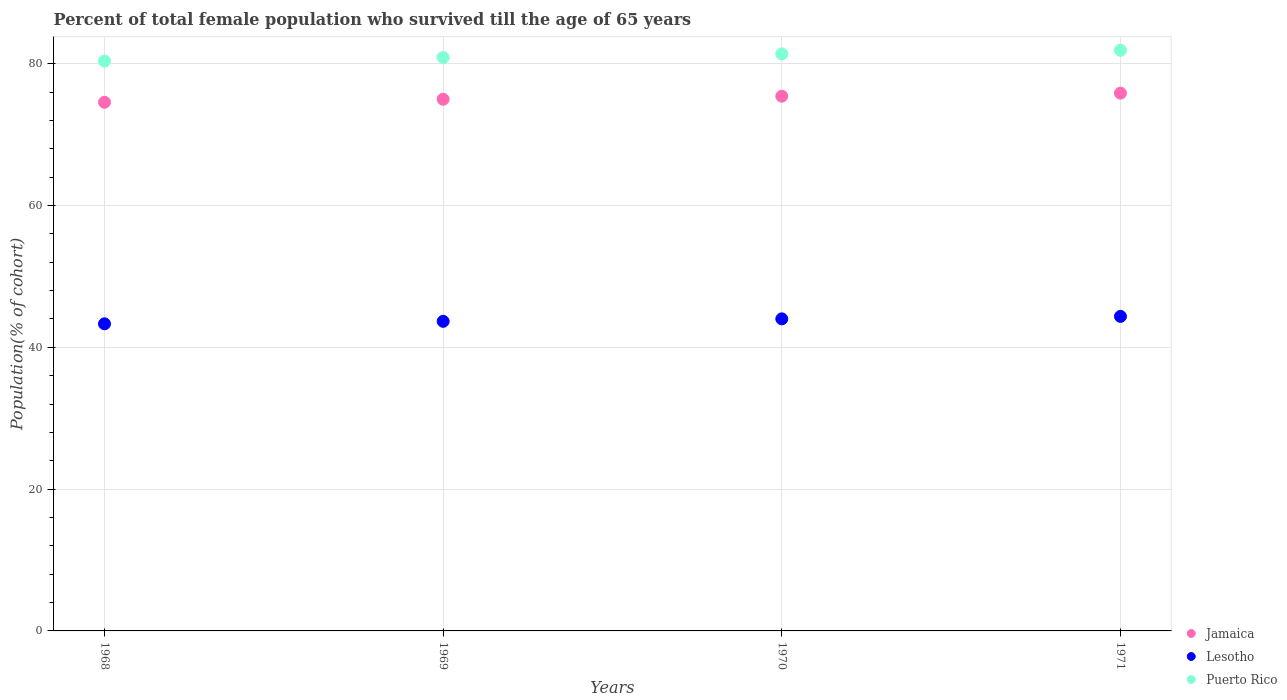What is the percentage of total female population who survived till the age of 65 years in Jamaica in 1969?
Ensure brevity in your answer.  74.99. Across all years, what is the maximum percentage of total female population who survived till the age of 65 years in Jamaica?
Provide a succinct answer. 75.85. Across all years, what is the minimum percentage of total female population who survived till the age of 65 years in Jamaica?
Give a very brief answer. 74.56. In which year was the percentage of total female population who survived till the age of 65 years in Jamaica maximum?
Offer a terse response. 1971. In which year was the percentage of total female population who survived till the age of 65 years in Jamaica minimum?
Provide a short and direct response. 1968. What is the total percentage of total female population who survived till the age of 65 years in Lesotho in the graph?
Offer a very short reply. 175.35. What is the difference between the percentage of total female population who survived till the age of 65 years in Puerto Rico in 1968 and that in 1969?
Offer a terse response. -0.51. What is the difference between the percentage of total female population who survived till the age of 65 years in Puerto Rico in 1971 and the percentage of total female population who survived till the age of 65 years in Lesotho in 1968?
Give a very brief answer. 38.58. What is the average percentage of total female population who survived till the age of 65 years in Lesotho per year?
Keep it short and to the point. 43.84. In the year 1971, what is the difference between the percentage of total female population who survived till the age of 65 years in Jamaica and percentage of total female population who survived till the age of 65 years in Puerto Rico?
Make the answer very short. -6.05. In how many years, is the percentage of total female population who survived till the age of 65 years in Jamaica greater than 40 %?
Give a very brief answer. 4. What is the ratio of the percentage of total female population who survived till the age of 65 years in Jamaica in 1970 to that in 1971?
Keep it short and to the point. 0.99. Is the percentage of total female population who survived till the age of 65 years in Lesotho in 1969 less than that in 1971?
Offer a very short reply. Yes. Is the difference between the percentage of total female population who survived till the age of 65 years in Jamaica in 1970 and 1971 greater than the difference between the percentage of total female population who survived till the age of 65 years in Puerto Rico in 1970 and 1971?
Give a very brief answer. Yes. What is the difference between the highest and the second highest percentage of total female population who survived till the age of 65 years in Jamaica?
Your response must be concise. 0.43. What is the difference between the highest and the lowest percentage of total female population who survived till the age of 65 years in Puerto Rico?
Provide a short and direct response. 1.53. In how many years, is the percentage of total female population who survived till the age of 65 years in Jamaica greater than the average percentage of total female population who survived till the age of 65 years in Jamaica taken over all years?
Offer a terse response. 2. Is it the case that in every year, the sum of the percentage of total female population who survived till the age of 65 years in Puerto Rico and percentage of total female population who survived till the age of 65 years in Lesotho  is greater than the percentage of total female population who survived till the age of 65 years in Jamaica?
Provide a succinct answer. Yes. How many dotlines are there?
Ensure brevity in your answer.  3. Are the values on the major ticks of Y-axis written in scientific E-notation?
Provide a succinct answer. No. Does the graph contain any zero values?
Make the answer very short. No. Does the graph contain grids?
Provide a succinct answer. Yes. Where does the legend appear in the graph?
Give a very brief answer. Bottom right. How are the legend labels stacked?
Your answer should be very brief. Vertical. What is the title of the graph?
Give a very brief answer. Percent of total female population who survived till the age of 65 years. What is the label or title of the X-axis?
Offer a terse response. Years. What is the label or title of the Y-axis?
Keep it short and to the point. Population(% of cohort). What is the Population(% of cohort) of Jamaica in 1968?
Offer a very short reply. 74.56. What is the Population(% of cohort) in Lesotho in 1968?
Give a very brief answer. 43.31. What is the Population(% of cohort) in Puerto Rico in 1968?
Provide a succinct answer. 80.36. What is the Population(% of cohort) of Jamaica in 1969?
Provide a succinct answer. 74.99. What is the Population(% of cohort) of Lesotho in 1969?
Keep it short and to the point. 43.66. What is the Population(% of cohort) of Puerto Rico in 1969?
Offer a terse response. 80.87. What is the Population(% of cohort) of Jamaica in 1970?
Ensure brevity in your answer.  75.42. What is the Population(% of cohort) of Lesotho in 1970?
Offer a very short reply. 44.01. What is the Population(% of cohort) in Puerto Rico in 1970?
Offer a very short reply. 81.38. What is the Population(% of cohort) of Jamaica in 1971?
Your answer should be very brief. 75.85. What is the Population(% of cohort) of Lesotho in 1971?
Offer a very short reply. 44.36. What is the Population(% of cohort) in Puerto Rico in 1971?
Your answer should be compact. 81.9. Across all years, what is the maximum Population(% of cohort) of Jamaica?
Your answer should be very brief. 75.85. Across all years, what is the maximum Population(% of cohort) of Lesotho?
Offer a very short reply. 44.36. Across all years, what is the maximum Population(% of cohort) in Puerto Rico?
Provide a succinct answer. 81.9. Across all years, what is the minimum Population(% of cohort) of Jamaica?
Keep it short and to the point. 74.56. Across all years, what is the minimum Population(% of cohort) in Lesotho?
Make the answer very short. 43.31. Across all years, what is the minimum Population(% of cohort) in Puerto Rico?
Keep it short and to the point. 80.36. What is the total Population(% of cohort) of Jamaica in the graph?
Your answer should be very brief. 300.81. What is the total Population(% of cohort) in Lesotho in the graph?
Your answer should be very brief. 175.35. What is the total Population(% of cohort) in Puerto Rico in the graph?
Provide a succinct answer. 324.52. What is the difference between the Population(% of cohort) in Jamaica in 1968 and that in 1969?
Ensure brevity in your answer.  -0.43. What is the difference between the Population(% of cohort) of Lesotho in 1968 and that in 1969?
Offer a very short reply. -0.35. What is the difference between the Population(% of cohort) in Puerto Rico in 1968 and that in 1969?
Your answer should be very brief. -0.51. What is the difference between the Population(% of cohort) of Jamaica in 1968 and that in 1970?
Your response must be concise. -0.86. What is the difference between the Population(% of cohort) in Lesotho in 1968 and that in 1970?
Your answer should be compact. -0.7. What is the difference between the Population(% of cohort) in Puerto Rico in 1968 and that in 1970?
Keep it short and to the point. -1.02. What is the difference between the Population(% of cohort) in Jamaica in 1968 and that in 1971?
Provide a succinct answer. -1.29. What is the difference between the Population(% of cohort) in Lesotho in 1968 and that in 1971?
Provide a succinct answer. -1.05. What is the difference between the Population(% of cohort) in Puerto Rico in 1968 and that in 1971?
Ensure brevity in your answer.  -1.53. What is the difference between the Population(% of cohort) in Jamaica in 1969 and that in 1970?
Keep it short and to the point. -0.43. What is the difference between the Population(% of cohort) in Lesotho in 1969 and that in 1970?
Keep it short and to the point. -0.35. What is the difference between the Population(% of cohort) in Puerto Rico in 1969 and that in 1970?
Offer a terse response. -0.51. What is the difference between the Population(% of cohort) of Jamaica in 1969 and that in 1971?
Make the answer very short. -0.86. What is the difference between the Population(% of cohort) in Lesotho in 1969 and that in 1971?
Provide a succinct answer. -0.7. What is the difference between the Population(% of cohort) in Puerto Rico in 1969 and that in 1971?
Keep it short and to the point. -1.02. What is the difference between the Population(% of cohort) in Jamaica in 1970 and that in 1971?
Keep it short and to the point. -0.43. What is the difference between the Population(% of cohort) of Lesotho in 1970 and that in 1971?
Your answer should be very brief. -0.35. What is the difference between the Population(% of cohort) of Puerto Rico in 1970 and that in 1971?
Your answer should be compact. -0.51. What is the difference between the Population(% of cohort) in Jamaica in 1968 and the Population(% of cohort) in Lesotho in 1969?
Provide a succinct answer. 30.89. What is the difference between the Population(% of cohort) of Jamaica in 1968 and the Population(% of cohort) of Puerto Rico in 1969?
Keep it short and to the point. -6.32. What is the difference between the Population(% of cohort) of Lesotho in 1968 and the Population(% of cohort) of Puerto Rico in 1969?
Keep it short and to the point. -37.56. What is the difference between the Population(% of cohort) of Jamaica in 1968 and the Population(% of cohort) of Lesotho in 1970?
Make the answer very short. 30.54. What is the difference between the Population(% of cohort) of Jamaica in 1968 and the Population(% of cohort) of Puerto Rico in 1970?
Make the answer very short. -6.83. What is the difference between the Population(% of cohort) in Lesotho in 1968 and the Population(% of cohort) in Puerto Rico in 1970?
Provide a succinct answer. -38.07. What is the difference between the Population(% of cohort) of Jamaica in 1968 and the Population(% of cohort) of Lesotho in 1971?
Ensure brevity in your answer.  30.2. What is the difference between the Population(% of cohort) in Jamaica in 1968 and the Population(% of cohort) in Puerto Rico in 1971?
Your response must be concise. -7.34. What is the difference between the Population(% of cohort) of Lesotho in 1968 and the Population(% of cohort) of Puerto Rico in 1971?
Offer a terse response. -38.58. What is the difference between the Population(% of cohort) in Jamaica in 1969 and the Population(% of cohort) in Lesotho in 1970?
Make the answer very short. 30.97. What is the difference between the Population(% of cohort) in Jamaica in 1969 and the Population(% of cohort) in Puerto Rico in 1970?
Offer a terse response. -6.4. What is the difference between the Population(% of cohort) in Lesotho in 1969 and the Population(% of cohort) in Puerto Rico in 1970?
Ensure brevity in your answer.  -37.72. What is the difference between the Population(% of cohort) of Jamaica in 1969 and the Population(% of cohort) of Lesotho in 1971?
Keep it short and to the point. 30.63. What is the difference between the Population(% of cohort) of Jamaica in 1969 and the Population(% of cohort) of Puerto Rico in 1971?
Provide a succinct answer. -6.91. What is the difference between the Population(% of cohort) in Lesotho in 1969 and the Population(% of cohort) in Puerto Rico in 1971?
Offer a terse response. -38.23. What is the difference between the Population(% of cohort) in Jamaica in 1970 and the Population(% of cohort) in Lesotho in 1971?
Offer a very short reply. 31.06. What is the difference between the Population(% of cohort) of Jamaica in 1970 and the Population(% of cohort) of Puerto Rico in 1971?
Provide a succinct answer. -6.48. What is the difference between the Population(% of cohort) in Lesotho in 1970 and the Population(% of cohort) in Puerto Rico in 1971?
Offer a terse response. -37.88. What is the average Population(% of cohort) of Jamaica per year?
Give a very brief answer. 75.2. What is the average Population(% of cohort) in Lesotho per year?
Offer a very short reply. 43.84. What is the average Population(% of cohort) of Puerto Rico per year?
Provide a short and direct response. 81.13. In the year 1968, what is the difference between the Population(% of cohort) of Jamaica and Population(% of cohort) of Lesotho?
Ensure brevity in your answer.  31.24. In the year 1968, what is the difference between the Population(% of cohort) of Jamaica and Population(% of cohort) of Puerto Rico?
Make the answer very short. -5.81. In the year 1968, what is the difference between the Population(% of cohort) in Lesotho and Population(% of cohort) in Puerto Rico?
Give a very brief answer. -37.05. In the year 1969, what is the difference between the Population(% of cohort) in Jamaica and Population(% of cohort) in Lesotho?
Your answer should be very brief. 31.32. In the year 1969, what is the difference between the Population(% of cohort) of Jamaica and Population(% of cohort) of Puerto Rico?
Offer a terse response. -5.89. In the year 1969, what is the difference between the Population(% of cohort) in Lesotho and Population(% of cohort) in Puerto Rico?
Your answer should be very brief. -37.21. In the year 1970, what is the difference between the Population(% of cohort) of Jamaica and Population(% of cohort) of Lesotho?
Offer a very short reply. 31.4. In the year 1970, what is the difference between the Population(% of cohort) in Jamaica and Population(% of cohort) in Puerto Rico?
Ensure brevity in your answer.  -5.97. In the year 1970, what is the difference between the Population(% of cohort) in Lesotho and Population(% of cohort) in Puerto Rico?
Your answer should be very brief. -37.37. In the year 1971, what is the difference between the Population(% of cohort) of Jamaica and Population(% of cohort) of Lesotho?
Your answer should be very brief. 31.49. In the year 1971, what is the difference between the Population(% of cohort) of Jamaica and Population(% of cohort) of Puerto Rico?
Offer a terse response. -6.05. In the year 1971, what is the difference between the Population(% of cohort) in Lesotho and Population(% of cohort) in Puerto Rico?
Your response must be concise. -37.53. What is the ratio of the Population(% of cohort) of Lesotho in 1968 to that in 1970?
Make the answer very short. 0.98. What is the ratio of the Population(% of cohort) in Puerto Rico in 1968 to that in 1970?
Keep it short and to the point. 0.99. What is the ratio of the Population(% of cohort) of Jamaica in 1968 to that in 1971?
Keep it short and to the point. 0.98. What is the ratio of the Population(% of cohort) in Lesotho in 1968 to that in 1971?
Provide a succinct answer. 0.98. What is the ratio of the Population(% of cohort) in Puerto Rico in 1968 to that in 1971?
Ensure brevity in your answer.  0.98. What is the ratio of the Population(% of cohort) of Puerto Rico in 1969 to that in 1970?
Offer a terse response. 0.99. What is the ratio of the Population(% of cohort) of Jamaica in 1969 to that in 1971?
Offer a very short reply. 0.99. What is the ratio of the Population(% of cohort) in Lesotho in 1969 to that in 1971?
Give a very brief answer. 0.98. What is the ratio of the Population(% of cohort) in Puerto Rico in 1969 to that in 1971?
Your answer should be very brief. 0.99. What is the ratio of the Population(% of cohort) in Lesotho in 1970 to that in 1971?
Your answer should be very brief. 0.99. What is the difference between the highest and the second highest Population(% of cohort) of Jamaica?
Keep it short and to the point. 0.43. What is the difference between the highest and the second highest Population(% of cohort) in Lesotho?
Give a very brief answer. 0.35. What is the difference between the highest and the second highest Population(% of cohort) of Puerto Rico?
Your answer should be very brief. 0.51. What is the difference between the highest and the lowest Population(% of cohort) of Jamaica?
Your answer should be very brief. 1.29. What is the difference between the highest and the lowest Population(% of cohort) in Lesotho?
Keep it short and to the point. 1.05. What is the difference between the highest and the lowest Population(% of cohort) of Puerto Rico?
Your answer should be compact. 1.53. 